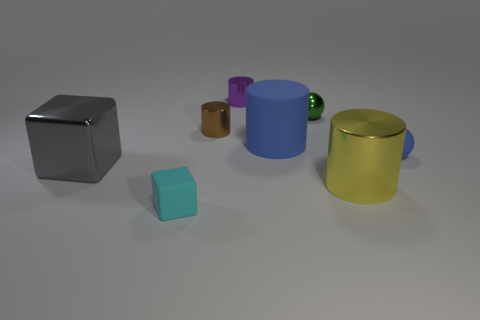There is a shiny cube; are there any small metal cylinders in front of it?
Provide a succinct answer. No. How many metal things are tiny cylinders or tiny brown things?
Provide a short and direct response. 2. There is a small green sphere; what number of tiny purple shiny cylinders are behind it?
Your response must be concise. 1. Is there a yellow thing of the same size as the gray shiny object?
Offer a terse response. Yes. Is there a tiny rubber cylinder that has the same color as the tiny matte sphere?
Make the answer very short. No. Is there anything else that has the same size as the brown cylinder?
Your answer should be compact. Yes. What number of small cylinders are the same color as the tiny shiny sphere?
Keep it short and to the point. 0. There is a matte cube; does it have the same color as the big cylinder that is in front of the large metallic cube?
Make the answer very short. No. What number of objects are small rubber spheres or metal things that are right of the small brown cylinder?
Your response must be concise. 4. There is a shiny cylinder that is in front of the big metal object to the left of the small purple cylinder; how big is it?
Provide a succinct answer. Large. 